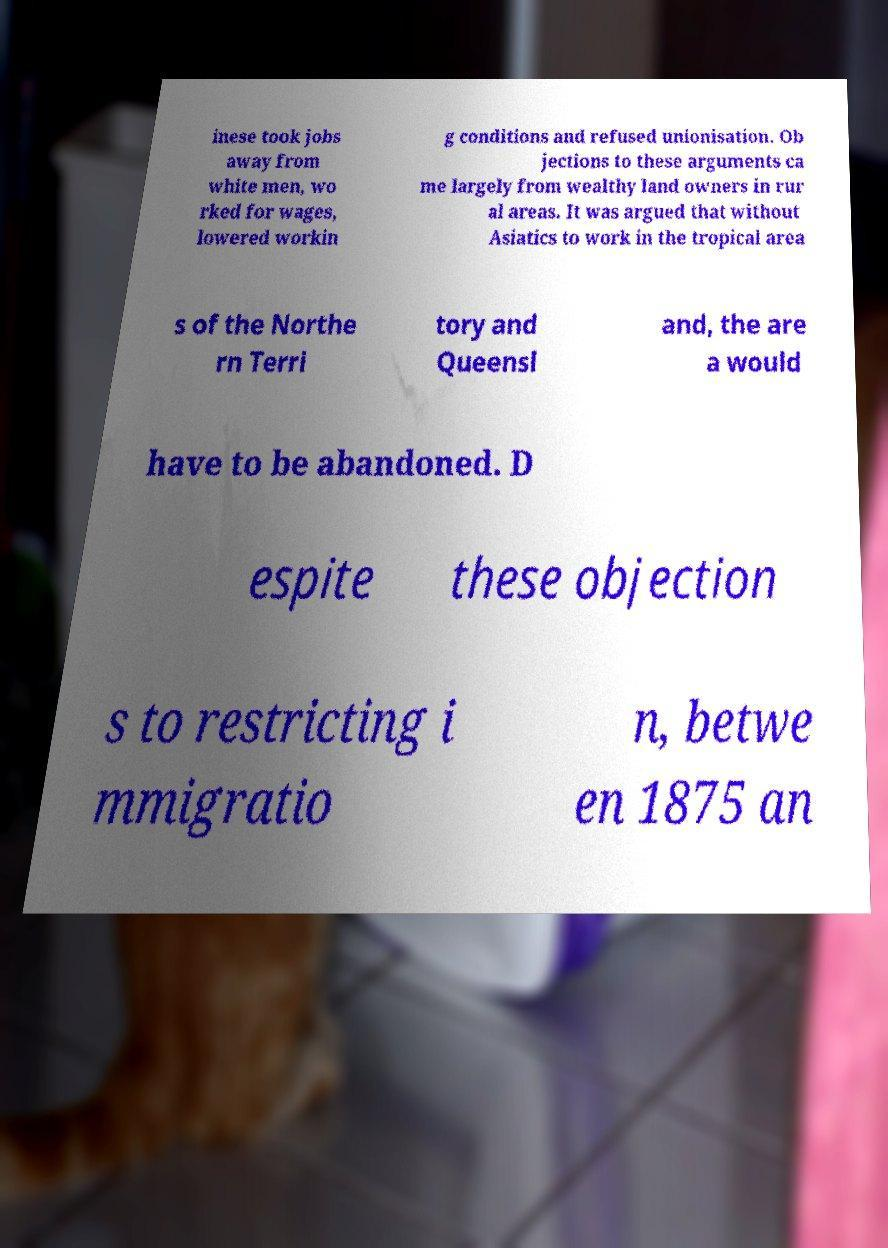Could you extract and type out the text from this image? inese took jobs away from white men, wo rked for wages, lowered workin g conditions and refused unionisation. Ob jections to these arguments ca me largely from wealthy land owners in rur al areas. It was argued that without Asiatics to work in the tropical area s of the Northe rn Terri tory and Queensl and, the are a would have to be abandoned. D espite these objection s to restricting i mmigratio n, betwe en 1875 an 